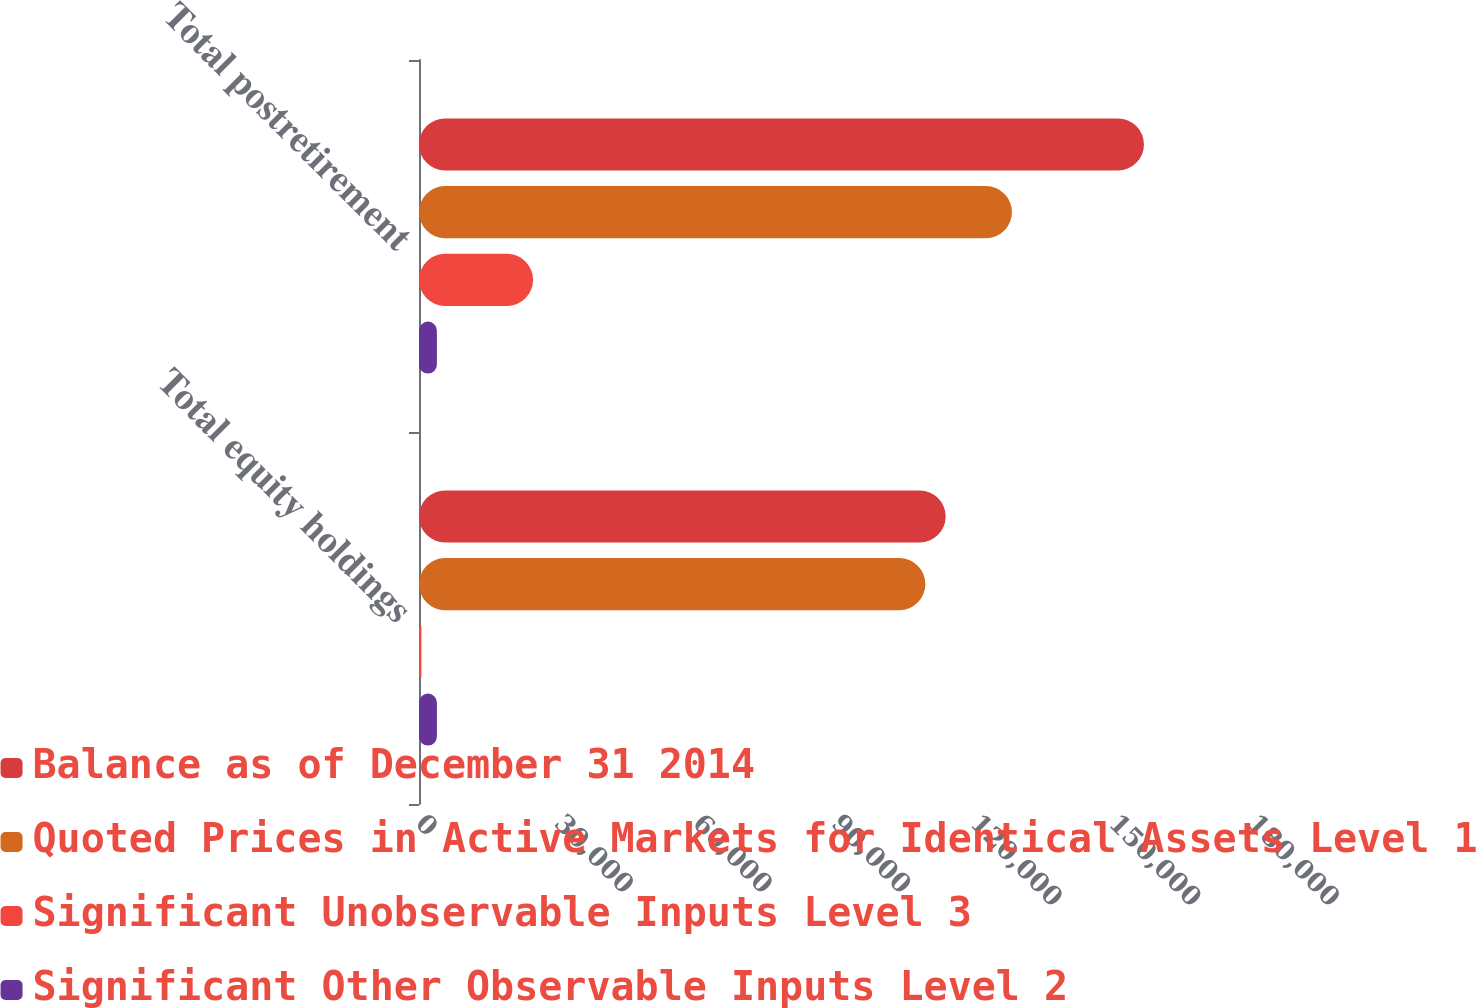<chart> <loc_0><loc_0><loc_500><loc_500><stacked_bar_chart><ecel><fcel>Total equity holdings<fcel>Total postretirement<nl><fcel>Balance as of December 31 2014<fcel>113942<fcel>156840<nl><fcel>Quoted Prices in Active Markets for Identical Assets Level 1<fcel>109552<fcel>128287<nl><fcel>Significant Unobservable Inputs Level 3<fcel>521<fcel>24684<nl><fcel>Significant Other Observable Inputs Level 2<fcel>3869<fcel>3869<nl></chart> 